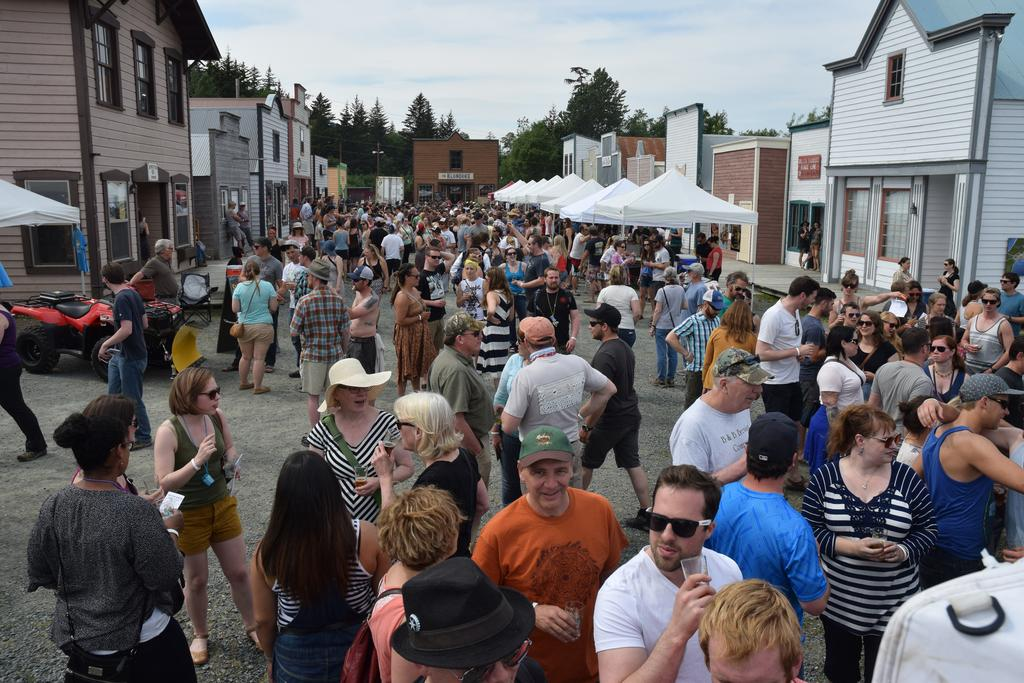What is the main subject of the image? The main subject of the image is a crowd of people. What are some people in the crowd wearing? Some people in the crowd are wearing caps and goggles. What type of structures can be seen in the image? There are buildings with windows in the image. What additional features are present in the image? There are tents and trees in the image, and the sky is visible in the background. Can you tell me how many fangs are visible on the people in the image? There are no fangs visible on the people in the image; they are wearing caps and goggles. What type of parent is present in the image? There is no parent present in the image; it features a crowd of people. 